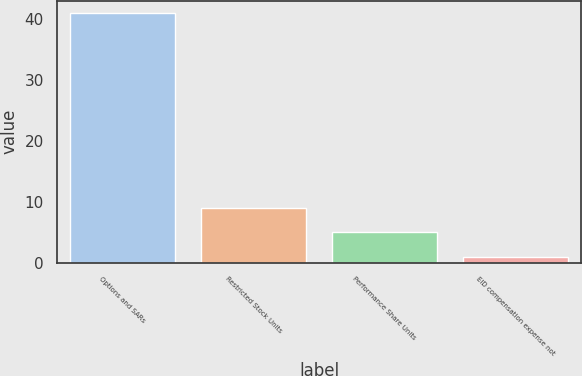Convert chart to OTSL. <chart><loc_0><loc_0><loc_500><loc_500><bar_chart><fcel>Options and SARs<fcel>Restricted Stock Units<fcel>Performance Share Units<fcel>EID compensation expense not<nl><fcel>41<fcel>9<fcel>5<fcel>1<nl></chart> 